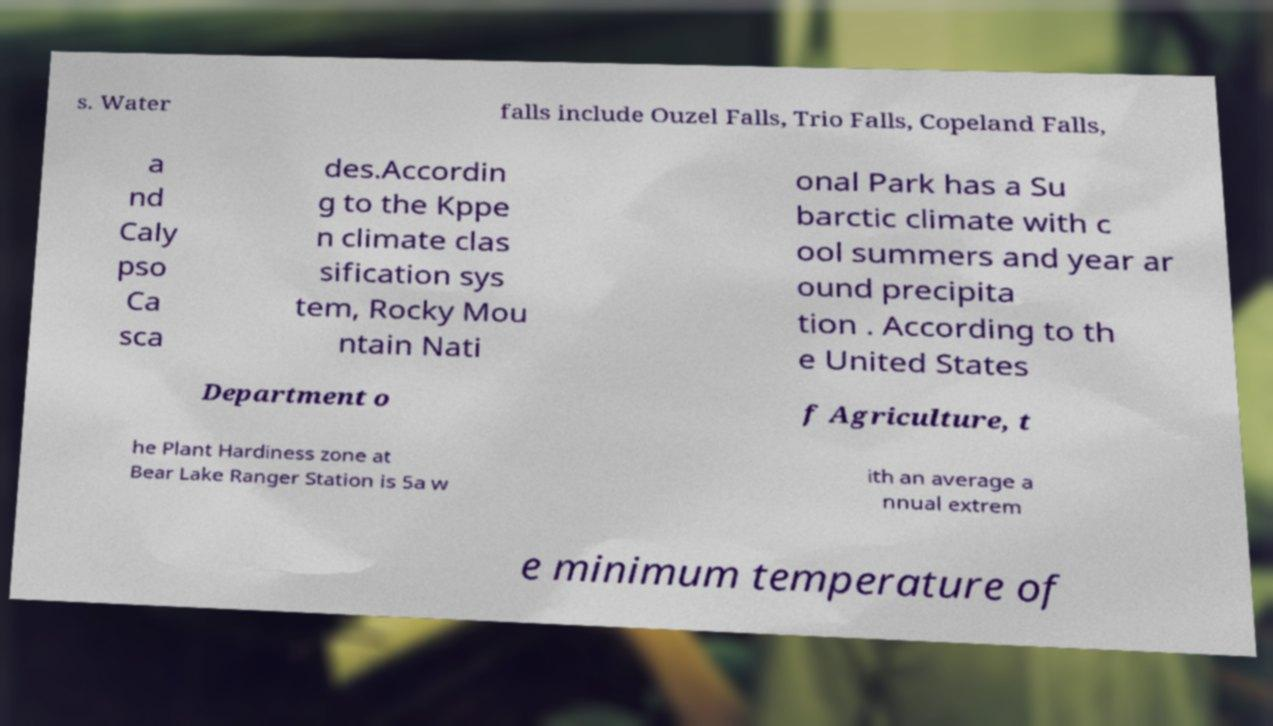Could you assist in decoding the text presented in this image and type it out clearly? s. Water falls include Ouzel Falls, Trio Falls, Copeland Falls, a nd Caly pso Ca sca des.Accordin g to the Kppe n climate clas sification sys tem, Rocky Mou ntain Nati onal Park has a Su barctic climate with c ool summers and year ar ound precipita tion . According to th e United States Department o f Agriculture, t he Plant Hardiness zone at Bear Lake Ranger Station is 5a w ith an average a nnual extrem e minimum temperature of 